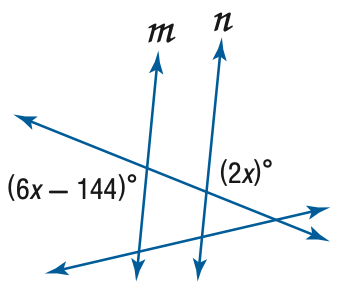Answer the mathemtical geometry problem and directly provide the correct option letter.
Question: Find x so that m \parallel n.
Choices: A: 18 B: 36 C: 38 D: 72 B 